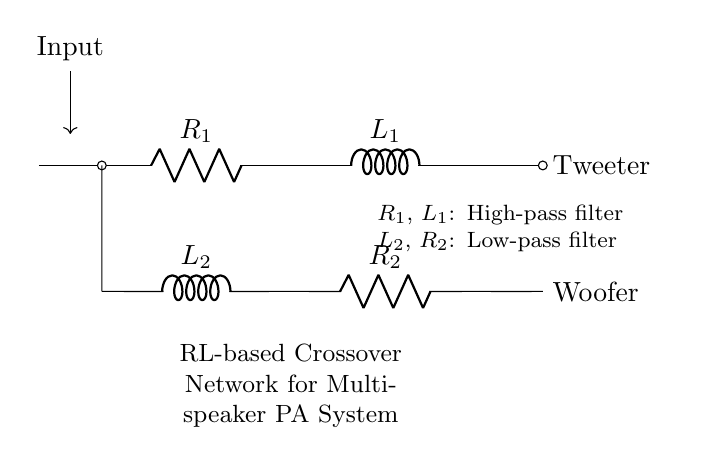What are the components in the circuit? The circuit contains two resistors and two inductors. Specifically, R1 and R2 are resistors, while L1 and L2 are inductors.
Answer: Resistors and inductors What is the purpose of R1 and L1? R1 and L1 form a high-pass filter, allowing high-frequency signals to pass while attenuating lower frequencies. This is essential for the tweeter connected at the output.
Answer: High-pass filter What is the output device for L2 and R2? L2 and R2 are configured as a low-pass filter, intended to drive the woofer by passing low-frequency signals while blocking higher frequencies.
Answer: Woofer What is the sequence of filters in the circuit? The high-pass filter (R1 and L1) is connected to the tweeter, while the low-pass filter (L2 and R2) is connected to the woofer. This arrangement ensures that each speaker receives suitable frequency ranges.
Answer: High-pass followed by low-pass What is the total number of inductors in the circuit? The circuit has two inductors, L1 and L2, connected in parallel to the resistors. Each inductor plays a role in defining the frequency response of the filters.
Answer: Two Which component primarily affects high frequencies? The inductor L1 primarily affects high frequencies in the high-pass filter configuration, enabling higher frequency signals to pass through to the tweeter.
Answer: L1 